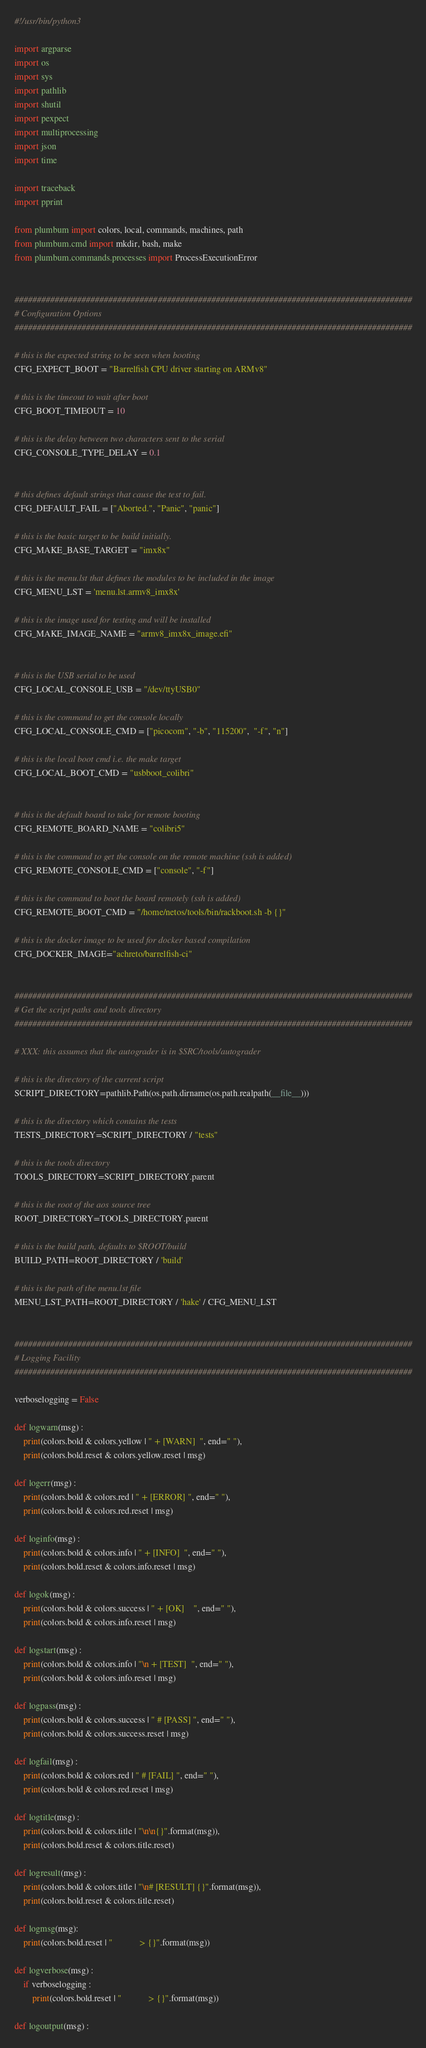<code> <loc_0><loc_0><loc_500><loc_500><_Python_>#!/usr/bin/python3

import argparse
import os
import sys
import pathlib
import shutil
import pexpect
import multiprocessing
import json
import time

import traceback
import pprint

from plumbum import colors, local, commands, machines, path
from plumbum.cmd import mkdir, bash, make
from plumbum.commands.processes import ProcessExecutionError


#########################################################################################
# Configuration Options
#########################################################################################

# this is the expected string to be seen when booting
CFG_EXPECT_BOOT = "Barrelfish CPU driver starting on ARMv8"

# this is the timeout to wait after boot
CFG_BOOT_TIMEOUT = 10

# this is the delay between two characters sent to the serial
CFG_CONSOLE_TYPE_DELAY = 0.1


# this defines default strings that cause the test to fail.
CFG_DEFAULT_FAIL = ["Aborted.", "Panic", "panic"]

# this is the basic target to be build initially.
CFG_MAKE_BASE_TARGET = "imx8x"

# this is the menu.lst that defines the modules to be included in the image
CFG_MENU_LST = 'menu.lst.armv8_imx8x'

# this is the image used for testing and will be installed
CFG_MAKE_IMAGE_NAME = "armv8_imx8x_image.efi"


# this is the USB serial to be used
CFG_LOCAL_CONSOLE_USB = "/dev/ttyUSB0"

# this is the command to get the console locally
CFG_LOCAL_CONSOLE_CMD = ["picocom", "-b", "115200",  "-f", "n"]

# this is the local boot cmd i.e. the make target
CFG_LOCAL_BOOT_CMD = "usbboot_colibri"


# this is the default board to take for remote booting
CFG_REMOTE_BOARD_NAME = "colibri5"

# this is the command to get the console on the remote machine (ssh is added)
CFG_REMOTE_CONSOLE_CMD = ["console", "-f"]

# this is the command to boot the board remotely (ssh is added)
CFG_REMOTE_BOOT_CMD = "/home/netos/tools/bin/rackboot.sh -b {}"

# this is the docker image to be used for docker based compilation
CFG_DOCKER_IMAGE="achreto/barrelfish-ci"


#########################################################################################
# Get the script paths and tools directory
#########################################################################################

# XXX: this assumes that the autograder is in $SRC/tools/autograder

# this is the directory of the current script
SCRIPT_DIRECTORY=pathlib.Path(os.path.dirname(os.path.realpath(__file__)))

# this is the directory which contains the tests
TESTS_DIRECTORY=SCRIPT_DIRECTORY / "tests"

# this is the tools directory
TOOLS_DIRECTORY=SCRIPT_DIRECTORY.parent

# this is the root of the aos source tree
ROOT_DIRECTORY=TOOLS_DIRECTORY.parent

# this is the build path, defaults to $ROOT/build
BUILD_PATH=ROOT_DIRECTORY / 'build'

# this is the path of the menu.lst file
MENU_LST_PATH=ROOT_DIRECTORY / 'hake' / CFG_MENU_LST


#########################################################################################
# Logging Facility
#########################################################################################

verboselogging = False

def logwarn(msg) :
    print(colors.bold & colors.yellow | " + [WARN]  ", end=" "),
    print(colors.bold.reset & colors.yellow.reset | msg)

def logerr(msg) :
    print(colors.bold & colors.red | " + [ERROR] ", end=" "),
    print(colors.bold & colors.red.reset | msg)

def loginfo(msg) :
    print(colors.bold & colors.info | " + [INFO]  ", end=" "),
    print(colors.bold.reset & colors.info.reset | msg)

def logok(msg) :
    print(colors.bold & colors.success | " + [OK]    ", end=" "),
    print(colors.bold & colors.info.reset | msg)

def logstart(msg) :
    print(colors.bold & colors.info | "\n + [TEST]  ", end=" "),
    print(colors.bold & colors.info.reset | msg)

def logpass(msg) :
    print(colors.bold & colors.success | " # [PASS] ", end=" "),
    print(colors.bold & colors.success.reset | msg)

def logfail(msg) :
    print(colors.bold & colors.red | " # [FAIL] ", end=" "),
    print(colors.bold & colors.red.reset | msg)

def logtitle(msg) :
    print(colors.bold & colors.title | "\n\n{}".format(msg)),
    print(colors.bold.reset & colors.title.reset)

def logresult(msg) :
    print(colors.bold & colors.title | "\n# [RESULT] {}".format(msg)),
    print(colors.bold.reset & colors.title.reset)

def logmsg(msg):
    print(colors.bold.reset | "            > {}".format(msg))

def logverbose(msg) :
    if verboselogging :
        print(colors.bold.reset | "            > {}".format(msg))

def logoutput(msg) :</code> 